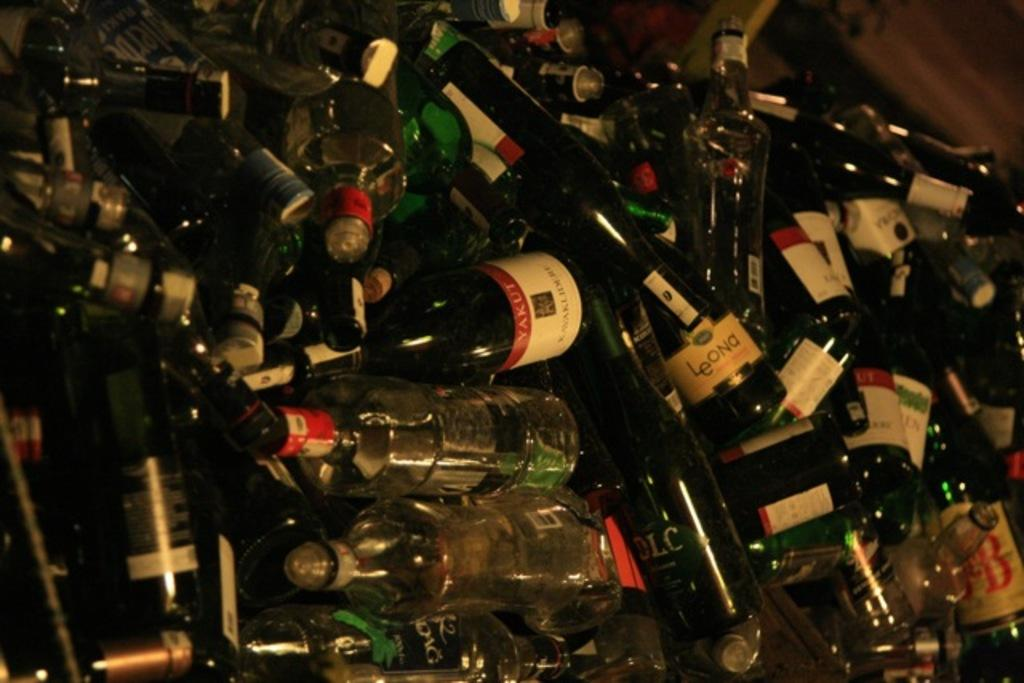What is the primary subject of the image? The primary subject of the image is many wine bottles. Can you describe the wine bottles in the image? There are many wine bottles visible in the image. What type of rings can be seen on the wine bottles in the image? There are no rings visible on the wine bottles in the image. What reward is being given to the person who collected the most wine bottles in the image? There is no reward or competition depicted in the image; it simply shows many wine bottles. What government policy is being discussed in relation to the wine bottles in the image? There is no discussion of government policy or any political context in the image; it only shows wine bottles. 